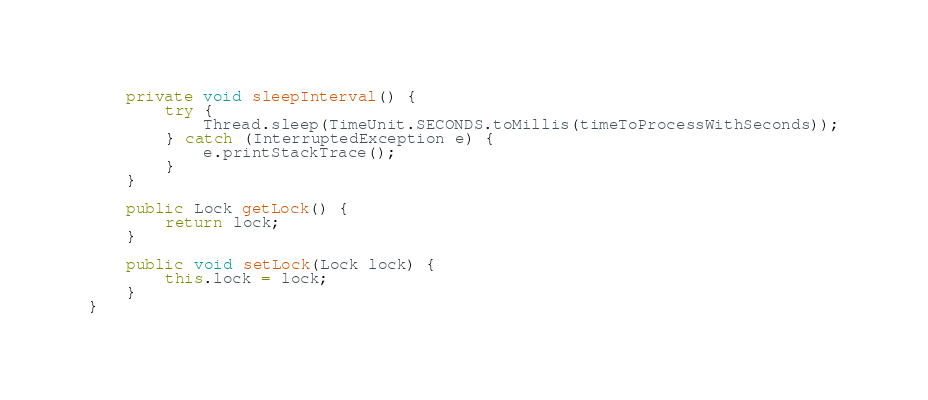<code> <loc_0><loc_0><loc_500><loc_500><_Java_>
    private void sleepInterval() {
        try {
            Thread.sleep(TimeUnit.SECONDS.toMillis(timeToProcessWithSeconds));
        } catch (InterruptedException e) {
            e.printStackTrace();
        }
    }

    public Lock getLock() {
        return lock;
    }

    public void setLock(Lock lock) {
        this.lock = lock;
    }
}
</code> 